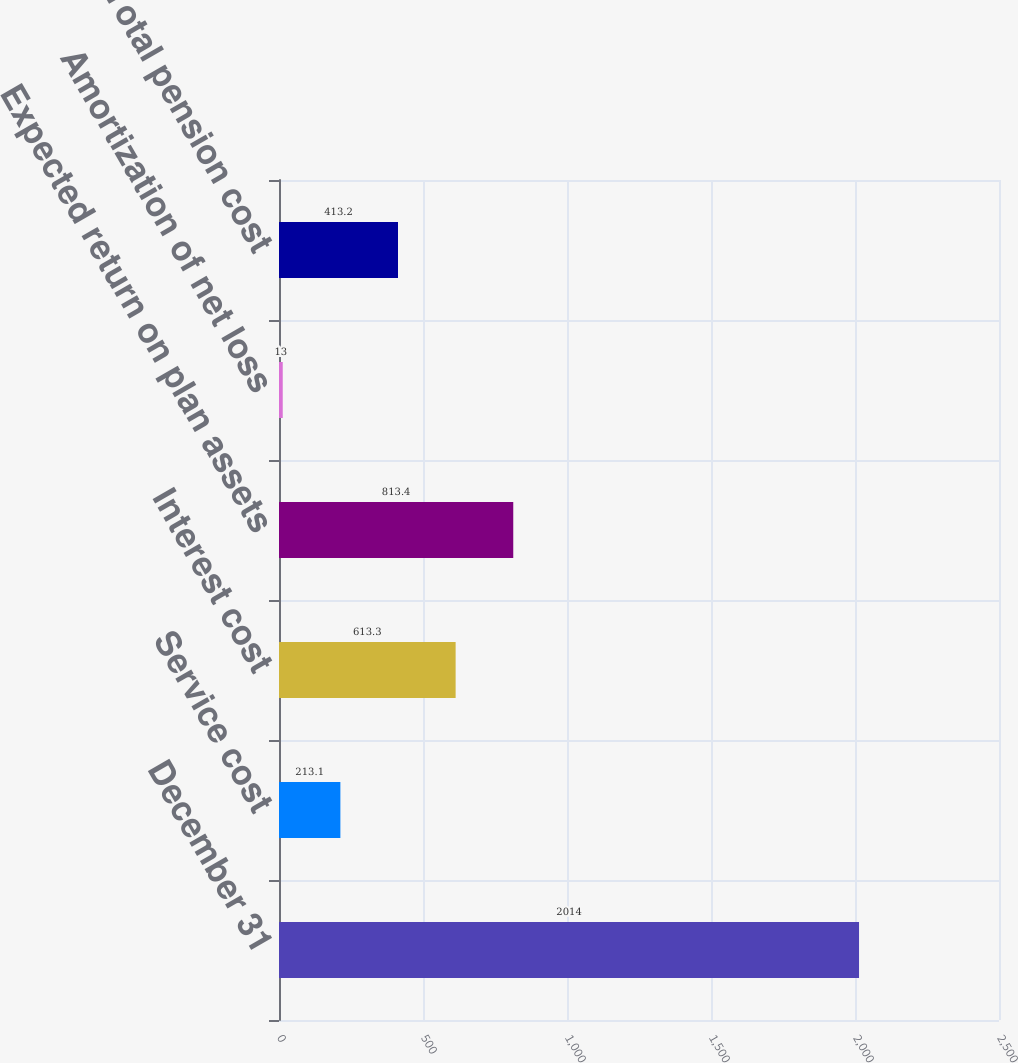Convert chart to OTSL. <chart><loc_0><loc_0><loc_500><loc_500><bar_chart><fcel>December 31<fcel>Service cost<fcel>Interest cost<fcel>Expected return on plan assets<fcel>Amortization of net loss<fcel>Total pension cost<nl><fcel>2014<fcel>213.1<fcel>613.3<fcel>813.4<fcel>13<fcel>413.2<nl></chart> 